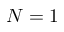<formula> <loc_0><loc_0><loc_500><loc_500>N = 1</formula> 